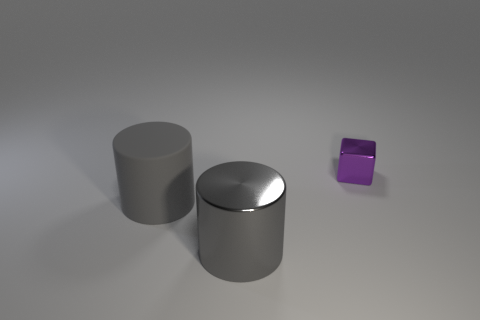Is there anything else that has the same size as the purple block?
Offer a very short reply. No. There is a metal thing on the left side of the block; is it the same shape as the large thing that is to the left of the big gray shiny object?
Give a very brief answer. Yes. Are there fewer large objects in front of the gray shiny cylinder than large gray cylinders that are in front of the small shiny block?
Make the answer very short. Yes. How many other objects are there of the same shape as the gray rubber thing?
Give a very brief answer. 1. There is a gray thing that is the same material as the purple thing; what shape is it?
Provide a succinct answer. Cylinder. What is the color of the thing that is behind the big metallic object and right of the gray matte object?
Offer a very short reply. Purple. Are the cylinder that is right of the big gray rubber thing and the small object made of the same material?
Ensure brevity in your answer.  Yes. Are there fewer small purple metallic objects that are left of the big matte cylinder than small cubes?
Offer a very short reply. Yes. Is there a cylinder that has the same material as the small purple cube?
Give a very brief answer. Yes. Is the size of the gray matte thing the same as the metal thing on the left side of the shiny block?
Your answer should be compact. Yes. 